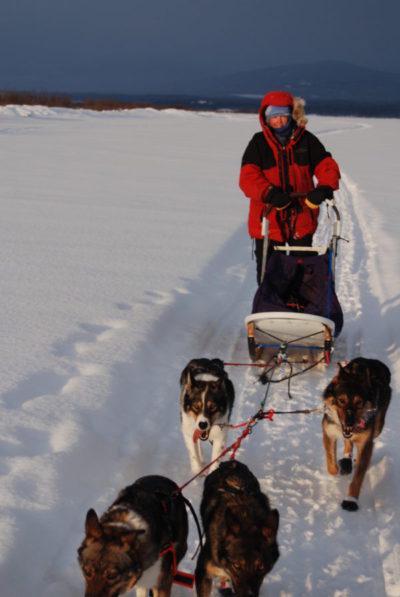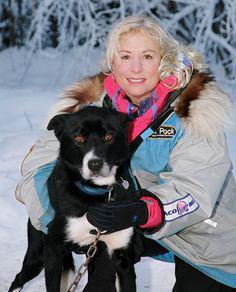The first image is the image on the left, the second image is the image on the right. Assess this claim about the two images: "There is one person holding at least one dog.". Correct or not? Answer yes or no. Yes. The first image is the image on the left, the second image is the image on the right. Examine the images to the left and right. Is the description "A camera-facing person in winter clothing is hugging at least one dog to their front, and the dog's body is turned toward the camera too." accurate? Answer yes or no. Yes. 